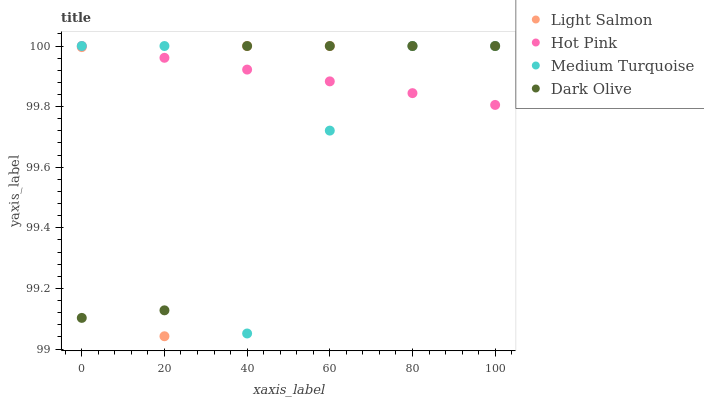Does Dark Olive have the minimum area under the curve?
Answer yes or no. Yes. Does Hot Pink have the maximum area under the curve?
Answer yes or no. Yes. Does Light Salmon have the minimum area under the curve?
Answer yes or no. No. Does Light Salmon have the maximum area under the curve?
Answer yes or no. No. Is Hot Pink the smoothest?
Answer yes or no. Yes. Is Medium Turquoise the roughest?
Answer yes or no. Yes. Is Light Salmon the smoothest?
Answer yes or no. No. Is Light Salmon the roughest?
Answer yes or no. No. Does Light Salmon have the lowest value?
Answer yes or no. Yes. Does Hot Pink have the lowest value?
Answer yes or no. No. Does Medium Turquoise have the highest value?
Answer yes or no. Yes. Does Light Salmon intersect Dark Olive?
Answer yes or no. Yes. Is Light Salmon less than Dark Olive?
Answer yes or no. No. Is Light Salmon greater than Dark Olive?
Answer yes or no. No. 